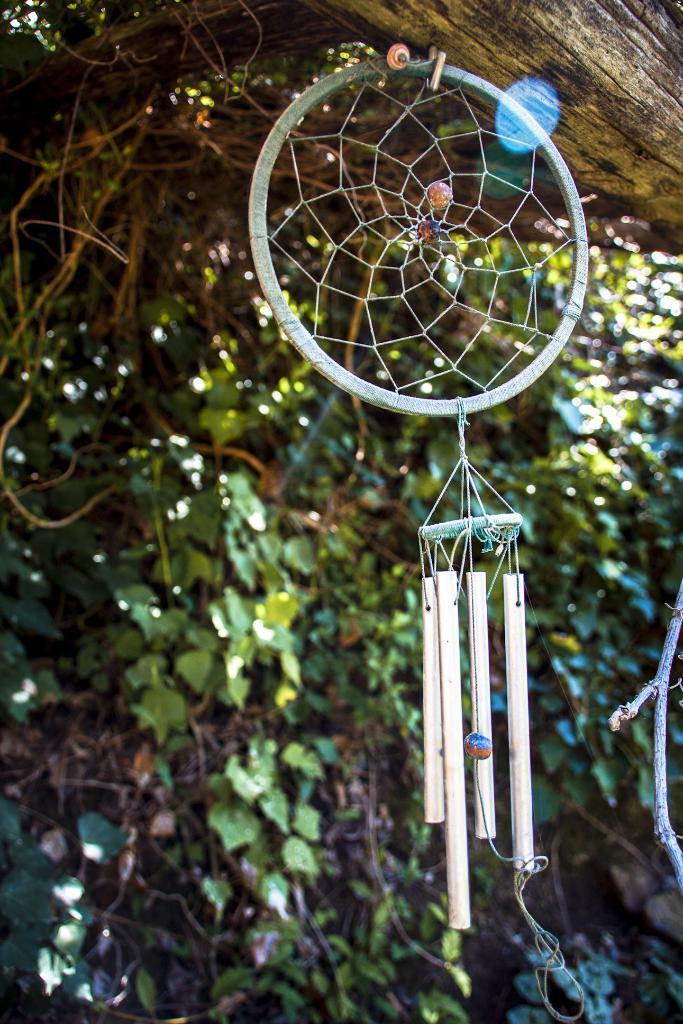Can you describe this image briefly? As we can see in the image there is tree and net. 